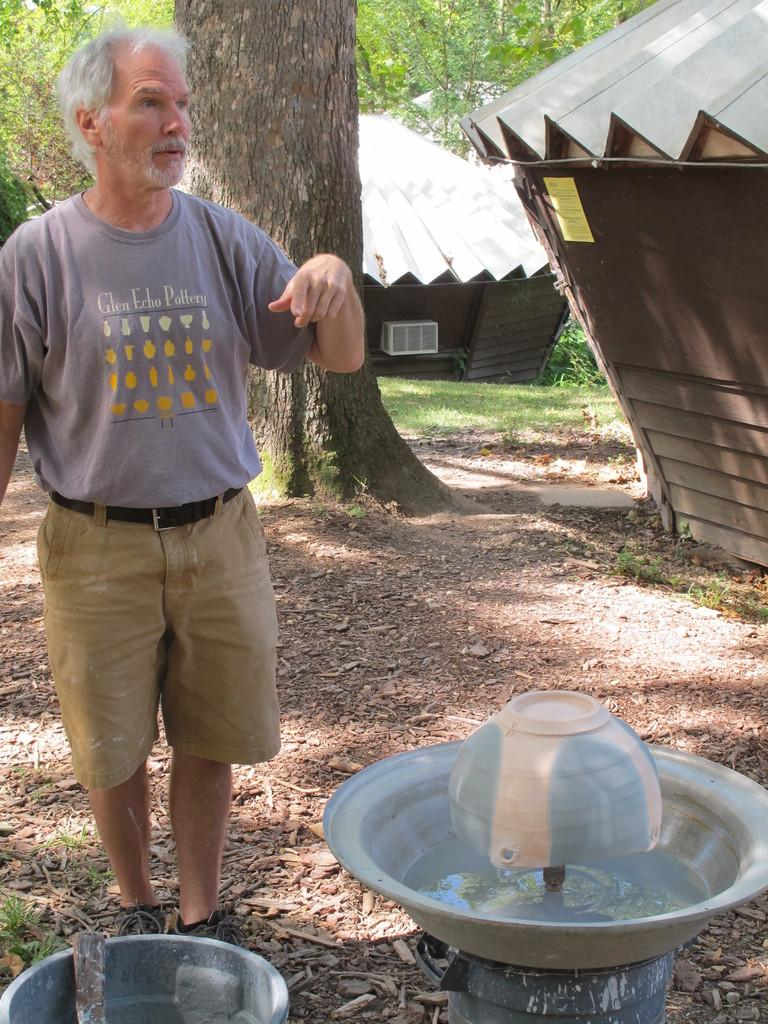<image>
Share a concise interpretation of the image provided. A man is working on making clay vases with a shirt that says Glen Echo Pottery. 